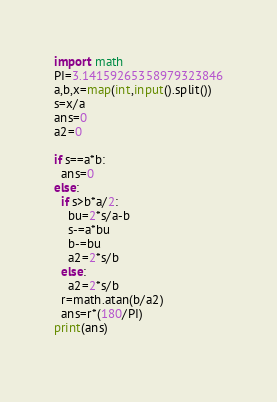Convert code to text. <code><loc_0><loc_0><loc_500><loc_500><_Python_>import math
PI=3.14159265358979323846
a,b,x=map(int,input().split())
s=x/a
ans=0
a2=0

if s==a*b:
  ans=0
else:
  if s>b*a/2:
    bu=2*s/a-b
    s-=a*bu
    b-=bu
    a2=2*s/b
  else:
    a2=2*s/b
  r=math.atan(b/a2)
  ans=r*(180/PI)
print(ans)
  </code> 